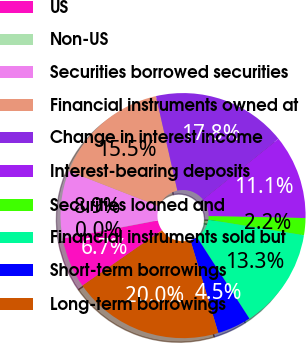Convert chart. <chart><loc_0><loc_0><loc_500><loc_500><pie_chart><fcel>US<fcel>Non-US<fcel>Securities borrowed securities<fcel>Financial instruments owned at<fcel>Change in interest income<fcel>Interest-bearing deposits<fcel>Securities loaned and<fcel>Financial instruments sold but<fcel>Short-term borrowings<fcel>Long-term borrowings<nl><fcel>6.68%<fcel>0.03%<fcel>8.89%<fcel>15.54%<fcel>17.75%<fcel>11.11%<fcel>2.25%<fcel>13.32%<fcel>4.46%<fcel>19.97%<nl></chart> 